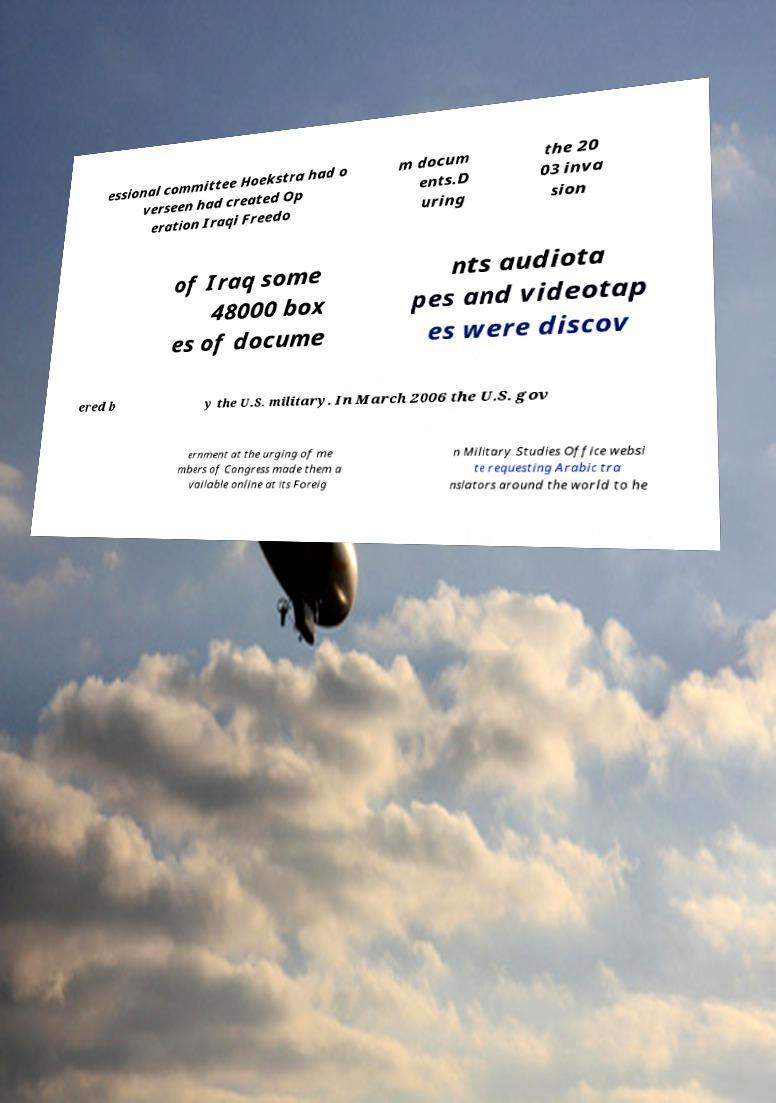Can you accurately transcribe the text from the provided image for me? essional committee Hoekstra had o verseen had created Op eration Iraqi Freedo m docum ents.D uring the 20 03 inva sion of Iraq some 48000 box es of docume nts audiota pes and videotap es were discov ered b y the U.S. military. In March 2006 the U.S. gov ernment at the urging of me mbers of Congress made them a vailable online at its Foreig n Military Studies Office websi te requesting Arabic tra nslators around the world to he 